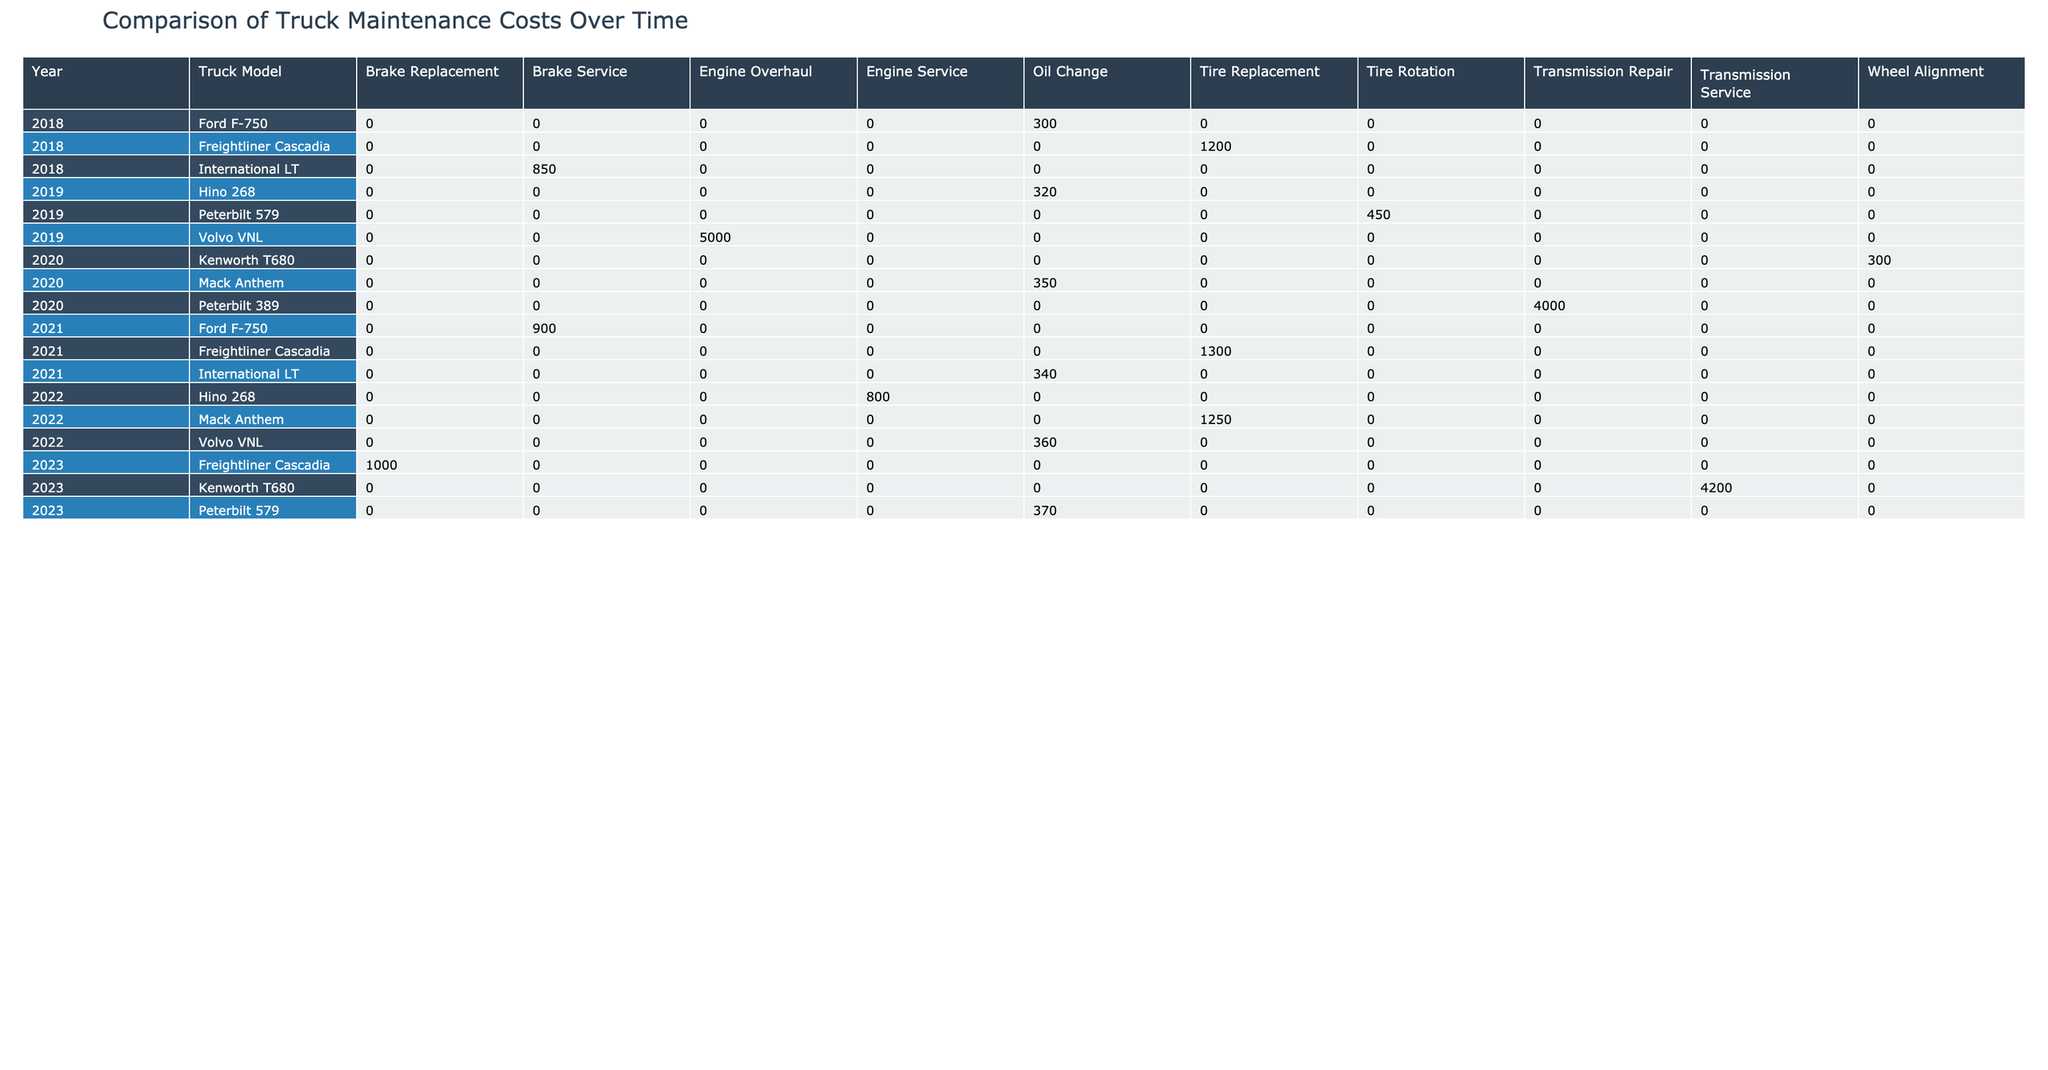What was the highest maintenance cost recorded in 2020? In 2020, the maintenance costs listed in the table are: Oil Change (350 USD), Transmission Repair (4000 USD), and Wheel Alignment (300 USD). The highest among these is 4000 USD for Transmission Repair.
Answer: 4000 USD Which truck model had the most maintenance types recorded in the table? Scanning through the truck models, Ford F-750, Freightliner Cascadia, International LT, and Volvo VNL each have multiple maintenance types listed. Specifically, Ford F-750 has Oil Change and Brake Service, while Freightliner Cascadia includes Tire Replacement and Brake Replacement, International LT has Oil Change and Brake Service, and Volvo VNL contains Oil Change and Engine Overhaul. Each model has 2 types, but no model exceeds this.
Answer: None, all have 2 types What is the total maintenance cost for the Volvo VNL across all years? The maintenance costs for Volvo VNL across the years are: 5000 USD in 2019 (Engine Overhaul), 360 USD in 2022 (Oil Change), and no listed costs in other years. Adding these amounts gives a total of 5000 + 360 = 5360 USD.
Answer: 5360 USD Did any truck model have its maintenance costs consistently increase each year from 2018 to 2023? By reviewing each truck model's costs year by year, none of the models showed a consistent increase. For instance, while Peterbilt 579 had 450 USD in 2019 and then went to 370 USD in 2023, this shows a decrease. After checking all models, we find that all had at least one decrease in costs.
Answer: No What is the average maintenance cost for all truck models in 2021? The maintenance costs in 2021 are: International LT (340 USD), Ford F-750 (900 USD), and Freightliner Cascadia (1300 USD). To calculate the average, sum them up: 340 + 900 + 1300 = 2540 USD, then divide by 3 (the number of models), which results in an average of 847 USD.
Answer: 847 USD In which location was the most expensive maintenance service performed in 2023? Checking the costs for 2023, Peterbilt 579 has an Oil Change at 370 USD, Kenworth T680 has a Transmission Service for 4200 USD, and Freightliner Cascadia has a Brake Replacement at 1000 USD. The highest cost was 4200 USD for Kenworth T680 in Virginia.
Answer: Virginia What was the difference in maintenance costs between the cheapest and most expensive truck services in 2019? Looking at the costs for 2019, the cheapest service is Hino 268 Oil Change at 320 USD, while the most expensive is Volvo VNL Engine Overhaul at 5000 USD. The difference is calculated as 5000 - 320 = 4680 USD.
Answer: 4680 USD Which year had the least total maintenance cost across all truck models? Summing up all the maintenance costs by year gives the following: 2018 (2850 USD), 2019 (5720 USD), 2020 (4650 USD), 2021 (2540 USD), 2022 (2410 USD), and 2023 (5570 USD). The least total is in 2021 with 2540 USD.
Answer: 2021 